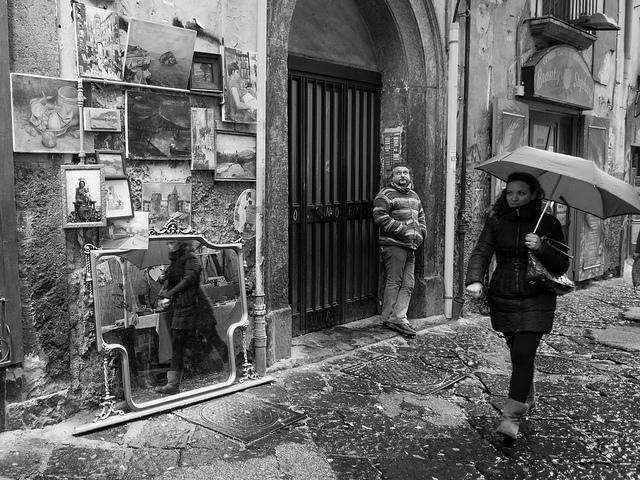How many people are there?
Give a very brief answer. 3. How many umbrellas are in the picture?
Give a very brief answer. 1. How many giraffes are there?
Give a very brief answer. 0. 